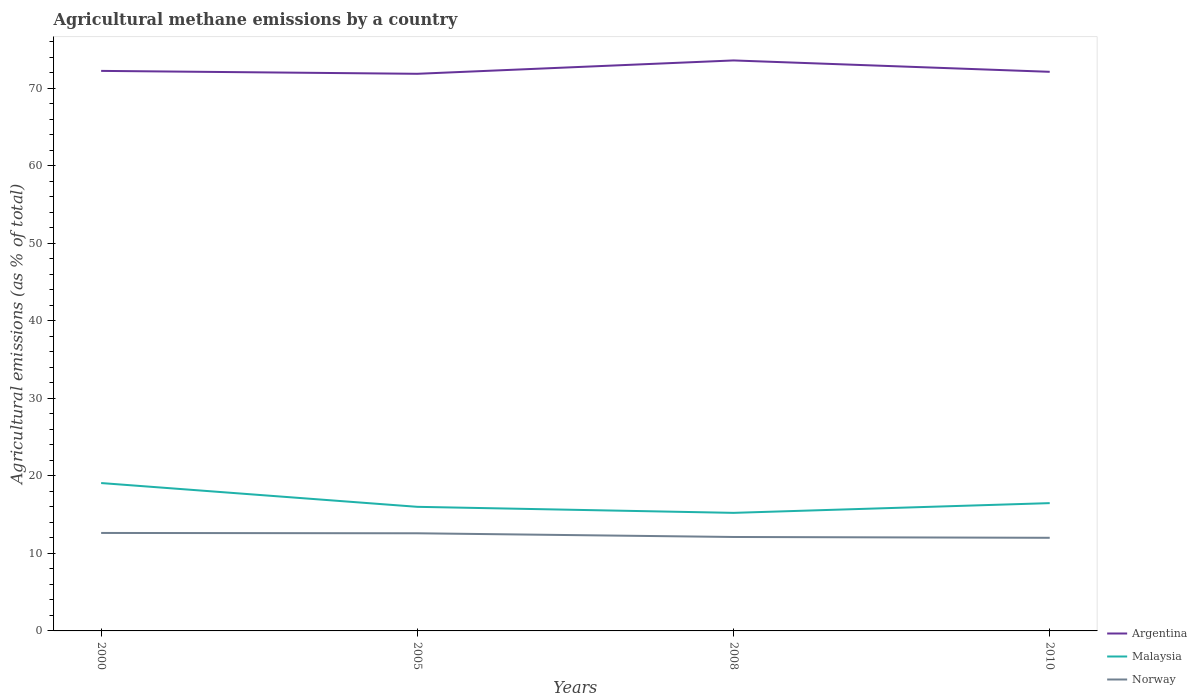How many different coloured lines are there?
Provide a short and direct response. 3. Does the line corresponding to Argentina intersect with the line corresponding to Norway?
Your response must be concise. No. Is the number of lines equal to the number of legend labels?
Your answer should be very brief. Yes. Across all years, what is the maximum amount of agricultural methane emitted in Norway?
Offer a very short reply. 12.02. What is the total amount of agricultural methane emitted in Argentina in the graph?
Your answer should be compact. 0.38. What is the difference between the highest and the second highest amount of agricultural methane emitted in Norway?
Give a very brief answer. 0.62. What is the difference between the highest and the lowest amount of agricultural methane emitted in Malaysia?
Your answer should be compact. 1. How many years are there in the graph?
Provide a succinct answer. 4. What is the difference between two consecutive major ticks on the Y-axis?
Your response must be concise. 10. Are the values on the major ticks of Y-axis written in scientific E-notation?
Your answer should be very brief. No. Does the graph contain any zero values?
Ensure brevity in your answer.  No. What is the title of the graph?
Ensure brevity in your answer.  Agricultural methane emissions by a country. What is the label or title of the X-axis?
Your response must be concise. Years. What is the label or title of the Y-axis?
Give a very brief answer. Agricultural emissions (as % of total). What is the Agricultural emissions (as % of total) of Argentina in 2000?
Keep it short and to the point. 72.26. What is the Agricultural emissions (as % of total) in Malaysia in 2000?
Provide a short and direct response. 19.08. What is the Agricultural emissions (as % of total) of Norway in 2000?
Your answer should be compact. 12.64. What is the Agricultural emissions (as % of total) in Argentina in 2005?
Keep it short and to the point. 71.88. What is the Agricultural emissions (as % of total) of Malaysia in 2005?
Your answer should be compact. 16.01. What is the Agricultural emissions (as % of total) of Norway in 2005?
Ensure brevity in your answer.  12.6. What is the Agricultural emissions (as % of total) of Argentina in 2008?
Offer a very short reply. 73.61. What is the Agricultural emissions (as % of total) of Malaysia in 2008?
Your answer should be very brief. 15.23. What is the Agricultural emissions (as % of total) in Norway in 2008?
Give a very brief answer. 12.12. What is the Agricultural emissions (as % of total) of Argentina in 2010?
Provide a short and direct response. 72.14. What is the Agricultural emissions (as % of total) in Malaysia in 2010?
Provide a short and direct response. 16.49. What is the Agricultural emissions (as % of total) of Norway in 2010?
Give a very brief answer. 12.02. Across all years, what is the maximum Agricultural emissions (as % of total) of Argentina?
Offer a terse response. 73.61. Across all years, what is the maximum Agricultural emissions (as % of total) of Malaysia?
Give a very brief answer. 19.08. Across all years, what is the maximum Agricultural emissions (as % of total) of Norway?
Offer a terse response. 12.64. Across all years, what is the minimum Agricultural emissions (as % of total) in Argentina?
Provide a short and direct response. 71.88. Across all years, what is the minimum Agricultural emissions (as % of total) of Malaysia?
Give a very brief answer. 15.23. Across all years, what is the minimum Agricultural emissions (as % of total) in Norway?
Offer a terse response. 12.02. What is the total Agricultural emissions (as % of total) of Argentina in the graph?
Ensure brevity in your answer.  289.89. What is the total Agricultural emissions (as % of total) of Malaysia in the graph?
Provide a succinct answer. 66.81. What is the total Agricultural emissions (as % of total) in Norway in the graph?
Keep it short and to the point. 49.37. What is the difference between the Agricultural emissions (as % of total) of Argentina in 2000 and that in 2005?
Make the answer very short. 0.38. What is the difference between the Agricultural emissions (as % of total) of Malaysia in 2000 and that in 2005?
Offer a very short reply. 3.07. What is the difference between the Agricultural emissions (as % of total) in Norway in 2000 and that in 2005?
Provide a short and direct response. 0.04. What is the difference between the Agricultural emissions (as % of total) of Argentina in 2000 and that in 2008?
Provide a short and direct response. -1.35. What is the difference between the Agricultural emissions (as % of total) of Malaysia in 2000 and that in 2008?
Your response must be concise. 3.85. What is the difference between the Agricultural emissions (as % of total) of Norway in 2000 and that in 2008?
Give a very brief answer. 0.52. What is the difference between the Agricultural emissions (as % of total) in Argentina in 2000 and that in 2010?
Your answer should be compact. 0.12. What is the difference between the Agricultural emissions (as % of total) of Malaysia in 2000 and that in 2010?
Your answer should be compact. 2.59. What is the difference between the Agricultural emissions (as % of total) of Norway in 2000 and that in 2010?
Provide a short and direct response. 0.62. What is the difference between the Agricultural emissions (as % of total) of Argentina in 2005 and that in 2008?
Give a very brief answer. -1.72. What is the difference between the Agricultural emissions (as % of total) in Malaysia in 2005 and that in 2008?
Provide a succinct answer. 0.78. What is the difference between the Agricultural emissions (as % of total) of Norway in 2005 and that in 2008?
Offer a very short reply. 0.48. What is the difference between the Agricultural emissions (as % of total) of Argentina in 2005 and that in 2010?
Offer a terse response. -0.26. What is the difference between the Agricultural emissions (as % of total) in Malaysia in 2005 and that in 2010?
Provide a succinct answer. -0.48. What is the difference between the Agricultural emissions (as % of total) of Norway in 2005 and that in 2010?
Your answer should be very brief. 0.58. What is the difference between the Agricultural emissions (as % of total) in Argentina in 2008 and that in 2010?
Keep it short and to the point. 1.47. What is the difference between the Agricultural emissions (as % of total) in Malaysia in 2008 and that in 2010?
Provide a succinct answer. -1.26. What is the difference between the Agricultural emissions (as % of total) of Norway in 2008 and that in 2010?
Offer a terse response. 0.1. What is the difference between the Agricultural emissions (as % of total) in Argentina in 2000 and the Agricultural emissions (as % of total) in Malaysia in 2005?
Give a very brief answer. 56.25. What is the difference between the Agricultural emissions (as % of total) of Argentina in 2000 and the Agricultural emissions (as % of total) of Norway in 2005?
Provide a short and direct response. 59.66. What is the difference between the Agricultural emissions (as % of total) of Malaysia in 2000 and the Agricultural emissions (as % of total) of Norway in 2005?
Your response must be concise. 6.48. What is the difference between the Agricultural emissions (as % of total) of Argentina in 2000 and the Agricultural emissions (as % of total) of Malaysia in 2008?
Offer a terse response. 57.03. What is the difference between the Agricultural emissions (as % of total) in Argentina in 2000 and the Agricultural emissions (as % of total) in Norway in 2008?
Make the answer very short. 60.14. What is the difference between the Agricultural emissions (as % of total) in Malaysia in 2000 and the Agricultural emissions (as % of total) in Norway in 2008?
Provide a succinct answer. 6.96. What is the difference between the Agricultural emissions (as % of total) of Argentina in 2000 and the Agricultural emissions (as % of total) of Malaysia in 2010?
Provide a short and direct response. 55.77. What is the difference between the Agricultural emissions (as % of total) in Argentina in 2000 and the Agricultural emissions (as % of total) in Norway in 2010?
Offer a very short reply. 60.24. What is the difference between the Agricultural emissions (as % of total) of Malaysia in 2000 and the Agricultural emissions (as % of total) of Norway in 2010?
Your response must be concise. 7.06. What is the difference between the Agricultural emissions (as % of total) in Argentina in 2005 and the Agricultural emissions (as % of total) in Malaysia in 2008?
Make the answer very short. 56.65. What is the difference between the Agricultural emissions (as % of total) of Argentina in 2005 and the Agricultural emissions (as % of total) of Norway in 2008?
Your answer should be compact. 59.76. What is the difference between the Agricultural emissions (as % of total) of Malaysia in 2005 and the Agricultural emissions (as % of total) of Norway in 2008?
Ensure brevity in your answer.  3.89. What is the difference between the Agricultural emissions (as % of total) of Argentina in 2005 and the Agricultural emissions (as % of total) of Malaysia in 2010?
Your answer should be very brief. 55.39. What is the difference between the Agricultural emissions (as % of total) of Argentina in 2005 and the Agricultural emissions (as % of total) of Norway in 2010?
Offer a very short reply. 59.87. What is the difference between the Agricultural emissions (as % of total) of Malaysia in 2005 and the Agricultural emissions (as % of total) of Norway in 2010?
Your response must be concise. 3.99. What is the difference between the Agricultural emissions (as % of total) of Argentina in 2008 and the Agricultural emissions (as % of total) of Malaysia in 2010?
Ensure brevity in your answer.  57.12. What is the difference between the Agricultural emissions (as % of total) in Argentina in 2008 and the Agricultural emissions (as % of total) in Norway in 2010?
Ensure brevity in your answer.  61.59. What is the difference between the Agricultural emissions (as % of total) of Malaysia in 2008 and the Agricultural emissions (as % of total) of Norway in 2010?
Provide a short and direct response. 3.22. What is the average Agricultural emissions (as % of total) in Argentina per year?
Keep it short and to the point. 72.47. What is the average Agricultural emissions (as % of total) of Malaysia per year?
Your answer should be compact. 16.7. What is the average Agricultural emissions (as % of total) in Norway per year?
Ensure brevity in your answer.  12.34. In the year 2000, what is the difference between the Agricultural emissions (as % of total) in Argentina and Agricultural emissions (as % of total) in Malaysia?
Your answer should be compact. 53.18. In the year 2000, what is the difference between the Agricultural emissions (as % of total) in Argentina and Agricultural emissions (as % of total) in Norway?
Offer a terse response. 59.62. In the year 2000, what is the difference between the Agricultural emissions (as % of total) of Malaysia and Agricultural emissions (as % of total) of Norway?
Your response must be concise. 6.44. In the year 2005, what is the difference between the Agricultural emissions (as % of total) of Argentina and Agricultural emissions (as % of total) of Malaysia?
Keep it short and to the point. 55.87. In the year 2005, what is the difference between the Agricultural emissions (as % of total) in Argentina and Agricultural emissions (as % of total) in Norway?
Offer a very short reply. 59.29. In the year 2005, what is the difference between the Agricultural emissions (as % of total) of Malaysia and Agricultural emissions (as % of total) of Norway?
Provide a succinct answer. 3.41. In the year 2008, what is the difference between the Agricultural emissions (as % of total) in Argentina and Agricultural emissions (as % of total) in Malaysia?
Give a very brief answer. 58.37. In the year 2008, what is the difference between the Agricultural emissions (as % of total) in Argentina and Agricultural emissions (as % of total) in Norway?
Your answer should be very brief. 61.49. In the year 2008, what is the difference between the Agricultural emissions (as % of total) of Malaysia and Agricultural emissions (as % of total) of Norway?
Provide a short and direct response. 3.11. In the year 2010, what is the difference between the Agricultural emissions (as % of total) of Argentina and Agricultural emissions (as % of total) of Malaysia?
Make the answer very short. 55.65. In the year 2010, what is the difference between the Agricultural emissions (as % of total) of Argentina and Agricultural emissions (as % of total) of Norway?
Your answer should be very brief. 60.12. In the year 2010, what is the difference between the Agricultural emissions (as % of total) of Malaysia and Agricultural emissions (as % of total) of Norway?
Ensure brevity in your answer.  4.47. What is the ratio of the Agricultural emissions (as % of total) of Argentina in 2000 to that in 2005?
Your answer should be compact. 1.01. What is the ratio of the Agricultural emissions (as % of total) of Malaysia in 2000 to that in 2005?
Provide a succinct answer. 1.19. What is the ratio of the Agricultural emissions (as % of total) in Argentina in 2000 to that in 2008?
Your response must be concise. 0.98. What is the ratio of the Agricultural emissions (as % of total) of Malaysia in 2000 to that in 2008?
Ensure brevity in your answer.  1.25. What is the ratio of the Agricultural emissions (as % of total) of Norway in 2000 to that in 2008?
Make the answer very short. 1.04. What is the ratio of the Agricultural emissions (as % of total) in Malaysia in 2000 to that in 2010?
Your response must be concise. 1.16. What is the ratio of the Agricultural emissions (as % of total) in Norway in 2000 to that in 2010?
Your response must be concise. 1.05. What is the ratio of the Agricultural emissions (as % of total) of Argentina in 2005 to that in 2008?
Keep it short and to the point. 0.98. What is the ratio of the Agricultural emissions (as % of total) of Malaysia in 2005 to that in 2008?
Ensure brevity in your answer.  1.05. What is the ratio of the Agricultural emissions (as % of total) in Norway in 2005 to that in 2008?
Your answer should be very brief. 1.04. What is the ratio of the Agricultural emissions (as % of total) of Argentina in 2005 to that in 2010?
Your response must be concise. 1. What is the ratio of the Agricultural emissions (as % of total) in Malaysia in 2005 to that in 2010?
Your answer should be very brief. 0.97. What is the ratio of the Agricultural emissions (as % of total) of Norway in 2005 to that in 2010?
Offer a very short reply. 1.05. What is the ratio of the Agricultural emissions (as % of total) of Argentina in 2008 to that in 2010?
Your response must be concise. 1.02. What is the ratio of the Agricultural emissions (as % of total) of Malaysia in 2008 to that in 2010?
Provide a short and direct response. 0.92. What is the ratio of the Agricultural emissions (as % of total) of Norway in 2008 to that in 2010?
Your answer should be compact. 1.01. What is the difference between the highest and the second highest Agricultural emissions (as % of total) of Argentina?
Your response must be concise. 1.35. What is the difference between the highest and the second highest Agricultural emissions (as % of total) of Malaysia?
Keep it short and to the point. 2.59. What is the difference between the highest and the second highest Agricultural emissions (as % of total) in Norway?
Ensure brevity in your answer.  0.04. What is the difference between the highest and the lowest Agricultural emissions (as % of total) of Argentina?
Offer a very short reply. 1.72. What is the difference between the highest and the lowest Agricultural emissions (as % of total) of Malaysia?
Your answer should be very brief. 3.85. What is the difference between the highest and the lowest Agricultural emissions (as % of total) of Norway?
Your response must be concise. 0.62. 